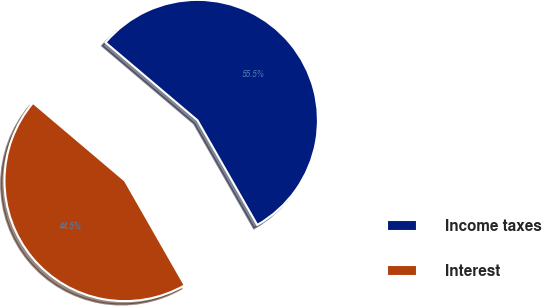<chart> <loc_0><loc_0><loc_500><loc_500><pie_chart><fcel>Income taxes<fcel>Interest<nl><fcel>55.55%<fcel>44.45%<nl></chart> 